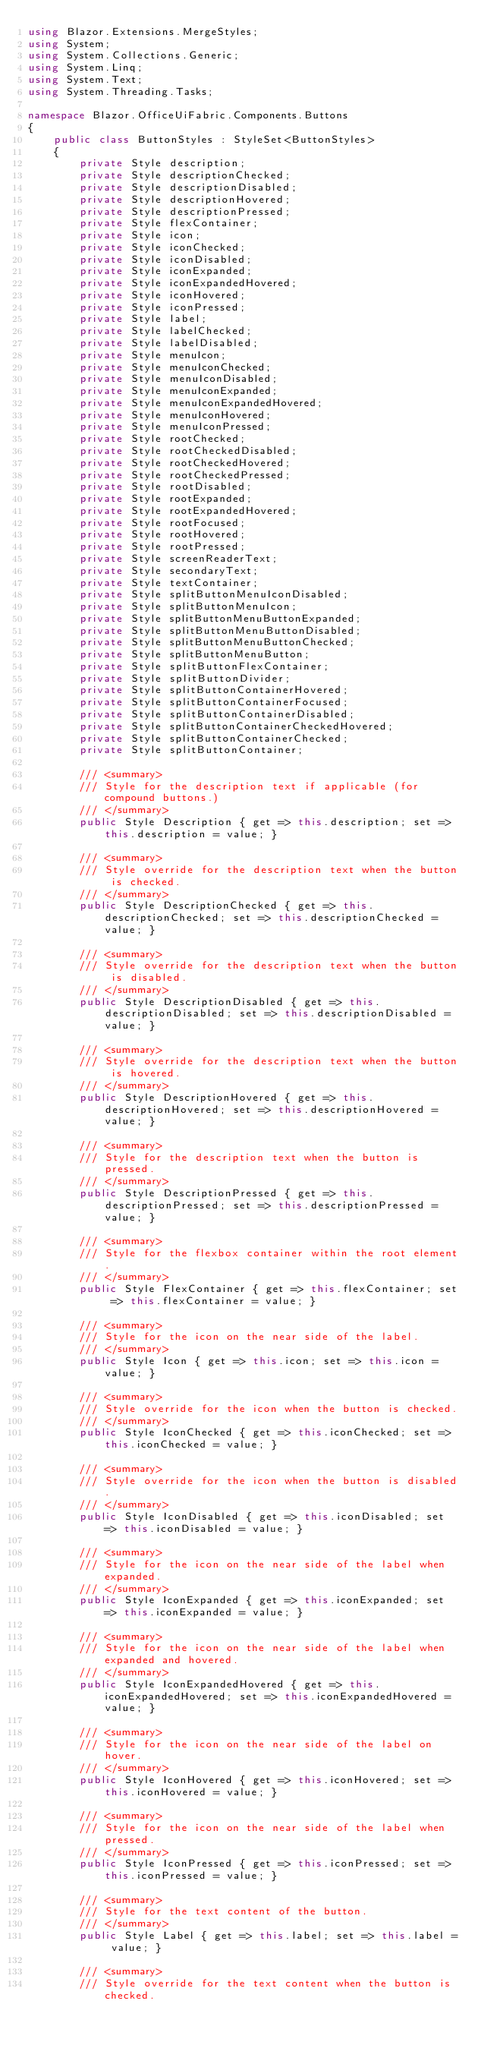<code> <loc_0><loc_0><loc_500><loc_500><_C#_>using Blazor.Extensions.MergeStyles;
using System;
using System.Collections.Generic;
using System.Linq;
using System.Text;
using System.Threading.Tasks;

namespace Blazor.OfficeUiFabric.Components.Buttons
{
    public class ButtonStyles : StyleSet<ButtonStyles>
    {
        private Style description;
        private Style descriptionChecked;
        private Style descriptionDisabled;
        private Style descriptionHovered;
        private Style descriptionPressed;
        private Style flexContainer;
        private Style icon;
        private Style iconChecked;
        private Style iconDisabled;
        private Style iconExpanded;
        private Style iconExpandedHovered;
        private Style iconHovered;
        private Style iconPressed;
        private Style label;
        private Style labelChecked;
        private Style labelDisabled;
        private Style menuIcon;
        private Style menuIconChecked;
        private Style menuIconDisabled;
        private Style menuIconExpanded;
        private Style menuIconExpandedHovered;
        private Style menuIconHovered;
        private Style menuIconPressed;
        private Style rootChecked;
        private Style rootCheckedDisabled;
        private Style rootCheckedHovered;
        private Style rootCheckedPressed;
        private Style rootDisabled;
        private Style rootExpanded;
        private Style rootExpandedHovered;
        private Style rootFocused;
        private Style rootHovered;
        private Style rootPressed;
        private Style screenReaderText;
        private Style secondaryText;
        private Style textContainer;
        private Style splitButtonMenuIconDisabled;
        private Style splitButtonMenuIcon;
        private Style splitButtonMenuButtonExpanded;
        private Style splitButtonMenuButtonDisabled;
        private Style splitButtonMenuButtonChecked;
        private Style splitButtonMenuButton;
        private Style splitButtonFlexContainer;
        private Style splitButtonDivider;
        private Style splitButtonContainerHovered;
        private Style splitButtonContainerFocused;
        private Style splitButtonContainerDisabled;
        private Style splitButtonContainerCheckedHovered;
        private Style splitButtonContainerChecked;
        private Style splitButtonContainer;

        /// <summary>
        /// Style for the description text if applicable (for compound buttons.)
        /// </summary>
        public Style Description { get => this.description; set => this.description = value; }

        /// <summary>
        /// Style override for the description text when the button is checked.
        /// </summary>
        public Style DescriptionChecked { get => this.descriptionChecked; set => this.descriptionChecked = value; }

        /// <summary>
        /// Style override for the description text when the button is disabled.
        /// </summary>
        public Style DescriptionDisabled { get => this.descriptionDisabled; set => this.descriptionDisabled = value; }

        /// <summary>
        /// Style override for the description text when the button is hovered.
        /// </summary>
        public Style DescriptionHovered { get => this.descriptionHovered; set => this.descriptionHovered = value; }

        /// <summary>
        /// Style for the description text when the button is pressed.
        /// </summary>
        public Style DescriptionPressed { get => this.descriptionPressed; set => this.descriptionPressed = value; }

        /// <summary>
        /// Style for the flexbox container within the root element.
        /// </summary>
        public Style FlexContainer { get => this.flexContainer; set => this.flexContainer = value; }

        /// <summary>
        /// Style for the icon on the near side of the label.
        /// </summary>
        public Style Icon { get => this.icon; set => this.icon = value; }

        /// <summary>
        /// Style override for the icon when the button is checked.
        /// </summary>
        public Style IconChecked { get => this.iconChecked; set => this.iconChecked = value; }

        /// <summary>
        /// Style override for the icon when the button is disabled.
        /// </summary>
        public Style IconDisabled { get => this.iconDisabled; set => this.iconDisabled = value; }

        /// <summary>
        /// Style for the icon on the near side of the label when expanded.
        /// </summary>
        public Style IconExpanded { get => this.iconExpanded; set => this.iconExpanded = value; }

        /// <summary>
        /// Style for the icon on the near side of the label when expanded and hovered.
        /// </summary>
        public Style IconExpandedHovered { get => this.iconExpandedHovered; set => this.iconExpandedHovered = value; }

        /// <summary>
        /// Style for the icon on the near side of the label on hover.
        /// </summary>
        public Style IconHovered { get => this.iconHovered; set => this.iconHovered = value; }

        /// <summary>
        /// Style for the icon on the near side of the label when pressed.
        /// </summary>
        public Style IconPressed { get => this.iconPressed; set => this.iconPressed = value; }

        /// <summary>
        /// Style for the text content of the button.
        /// </summary>
        public Style Label { get => this.label; set => this.label = value; }

        /// <summary>
        /// Style override for the text content when the button is checked.</code> 